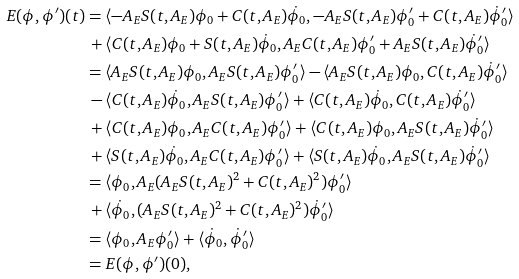Convert formula to latex. <formula><loc_0><loc_0><loc_500><loc_500>E ( \phi , \phi ^ { \prime } ) ( t ) & = \langle - A _ { E } S ( t , A _ { E } ) \phi _ { 0 } + C ( t , A _ { E } ) \dot { \phi } _ { 0 } , - A _ { E } S ( t , A _ { E } ) \phi _ { 0 } ^ { \prime } + C ( t , A _ { E } ) \dot { \phi } _ { 0 } ^ { \prime } \rangle \\ & \, + \langle C ( t , A _ { E } ) \phi _ { 0 } + S ( t , A _ { E } ) \dot { \phi } _ { 0 } , A _ { E } C ( t , A _ { E } ) \phi _ { 0 } ^ { \prime } + A _ { E } S ( t , A _ { E } ) \dot { \phi } _ { 0 } ^ { \prime } \rangle \\ & = \langle A _ { E } S ( t , A _ { E } ) \phi _ { 0 } , A _ { E } S ( t , A _ { E } ) \phi _ { 0 } ^ { \prime } \rangle - \langle A _ { E } S ( t , A _ { E } ) \phi _ { 0 } , C ( t , A _ { E } ) \dot { \phi } _ { 0 } ^ { \prime } \rangle \\ & \, - \langle C ( t , A _ { E } ) \dot { \phi } _ { 0 } , A _ { E } S ( t , A _ { E } ) \phi _ { 0 } ^ { \prime } \rangle + \langle C ( t , A _ { E } ) \dot { \phi } _ { 0 } , C ( t , A _ { E } ) \dot { \phi } _ { 0 } ^ { \prime } \rangle \\ & \, + \langle C ( t , A _ { E } ) \phi _ { 0 } , A _ { E } C ( t , A _ { E } ) \phi _ { 0 } ^ { \prime } \rangle + \langle C ( t , A _ { E } ) \phi _ { 0 } , A _ { E } S ( t , A _ { E } ) \dot { \phi } _ { 0 } ^ { \prime } \rangle \\ & \, + \langle S ( t , A _ { E } ) \dot { \phi } _ { 0 } , A _ { E } C ( t , A _ { E } ) \phi _ { 0 } ^ { \prime } \rangle + \langle S ( t , A _ { E } ) \dot { \phi } _ { 0 } , A _ { E } S ( t , A _ { E } ) \dot { \phi } _ { 0 } ^ { \prime } \rangle \\ & = \langle \phi _ { 0 } , A _ { E } ( A _ { E } S ( t , A _ { E } ) ^ { 2 } + C ( t , A _ { E } ) ^ { 2 } ) \phi _ { 0 } ^ { \prime } \rangle \\ & \, + \langle \dot { \phi } _ { 0 } , ( A _ { E } S ( t , A _ { E } ) ^ { 2 } + C ( t , A _ { E } ) ^ { 2 } ) \dot { \phi } _ { 0 } ^ { \prime } \rangle \\ & = \langle \phi _ { 0 } , A _ { E } \phi _ { 0 } ^ { \prime } \rangle + \langle \dot { \phi } _ { 0 } , \dot { \phi } _ { 0 } ^ { \prime } \rangle \\ & = E ( \phi , \phi ^ { \prime } ) ( 0 ) ,</formula> 